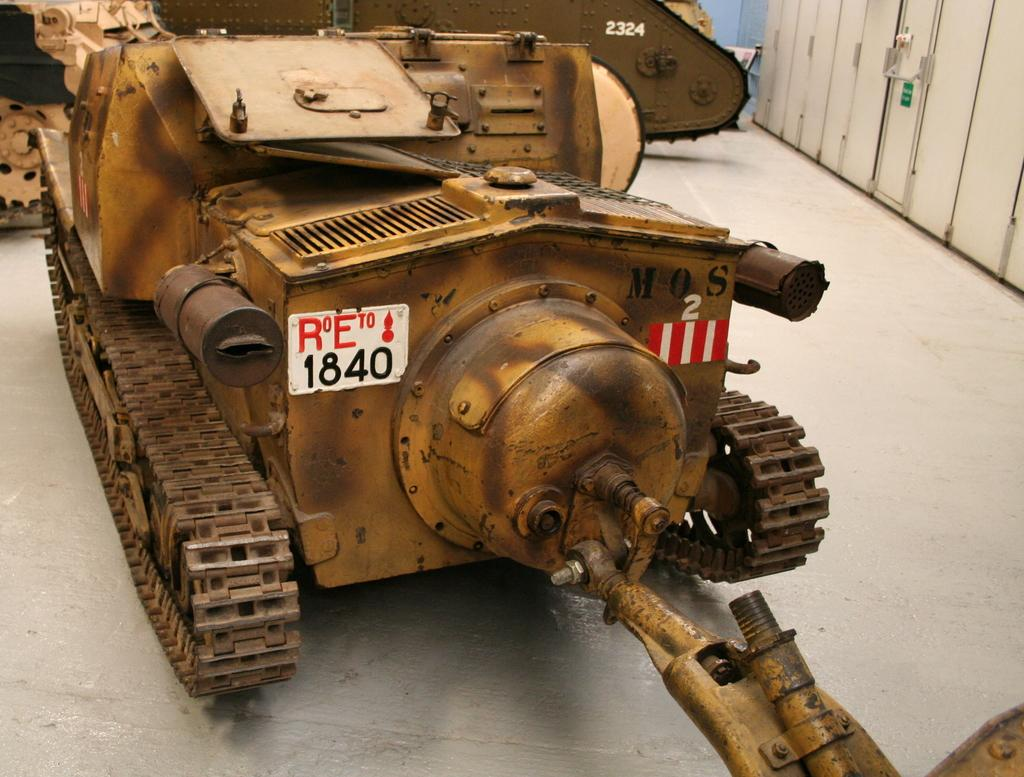What type of vehicle is in the picture? There is an ancient vehicle in the picture. Where is the ancient vehicle located? The ancient vehicle is on the floor. What color is the wall in the picture? There is a blue wall in the picture. Where is the blue wall in relation to the ancient vehicle? The blue wall is beside the ancient vehicle. What can be found beside the blue wall? There are doors beside the blue wall. Can you see a horse attacking the ancient vehicle in the image? There is no horse or attack present in the image; it features an ancient vehicle on the floor with a blue wall and doors beside it. 